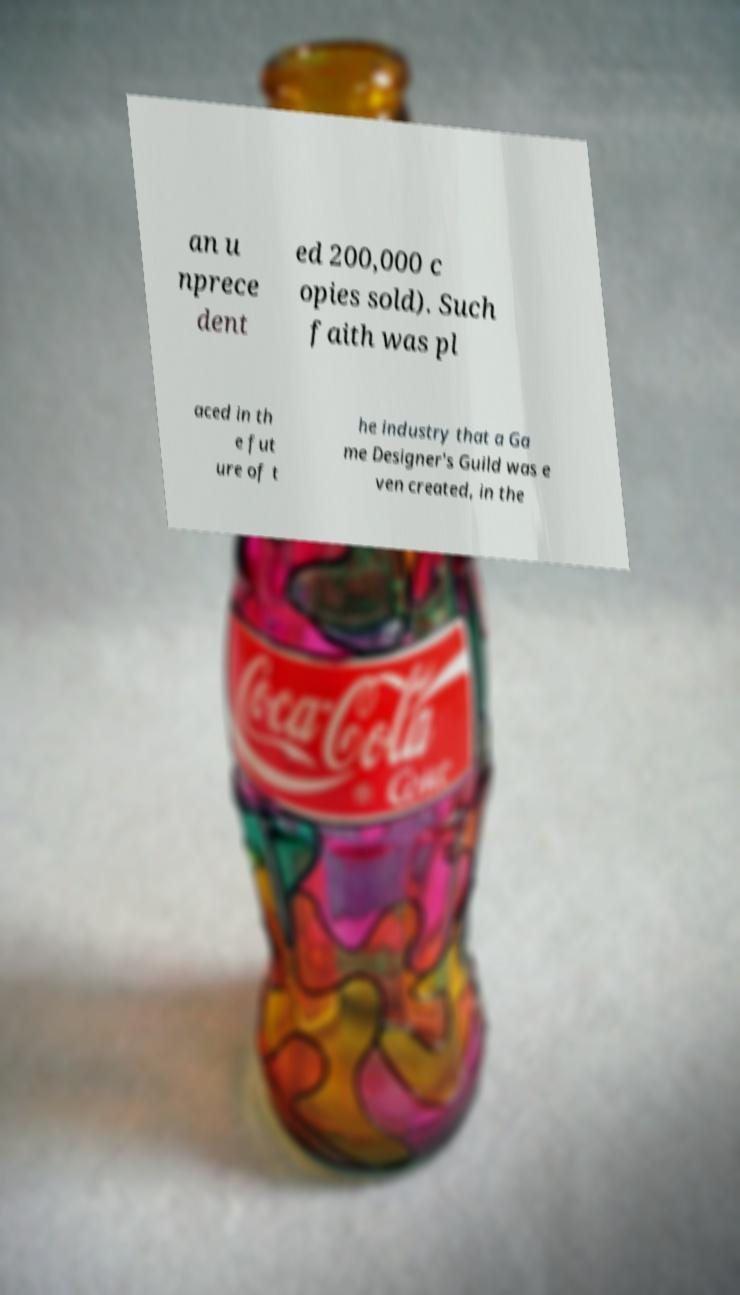Could you extract and type out the text from this image? an u nprece dent ed 200,000 c opies sold). Such faith was pl aced in th e fut ure of t he industry that a Ga me Designer's Guild was e ven created, in the 